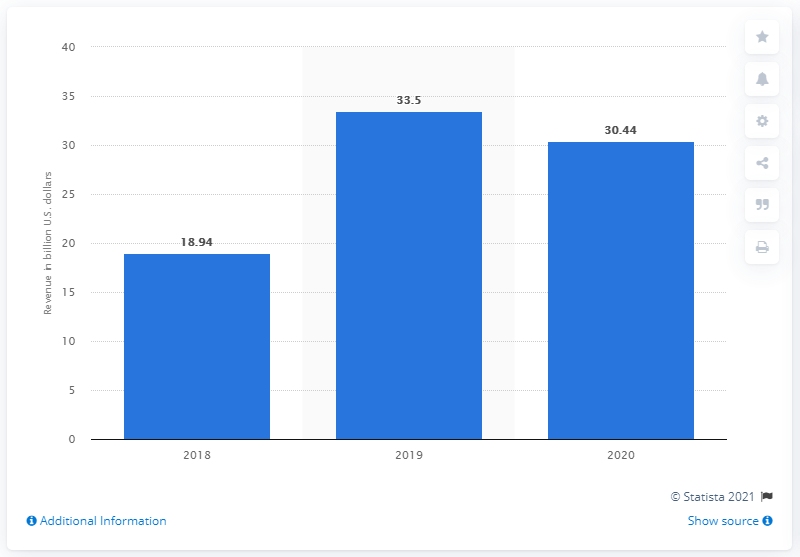Mention a couple of crucial points in this snapshot. In the previous year, WarnerMedia's revenue was 33.5... In 2020, WarnerMedia's total revenue was 30.44. 